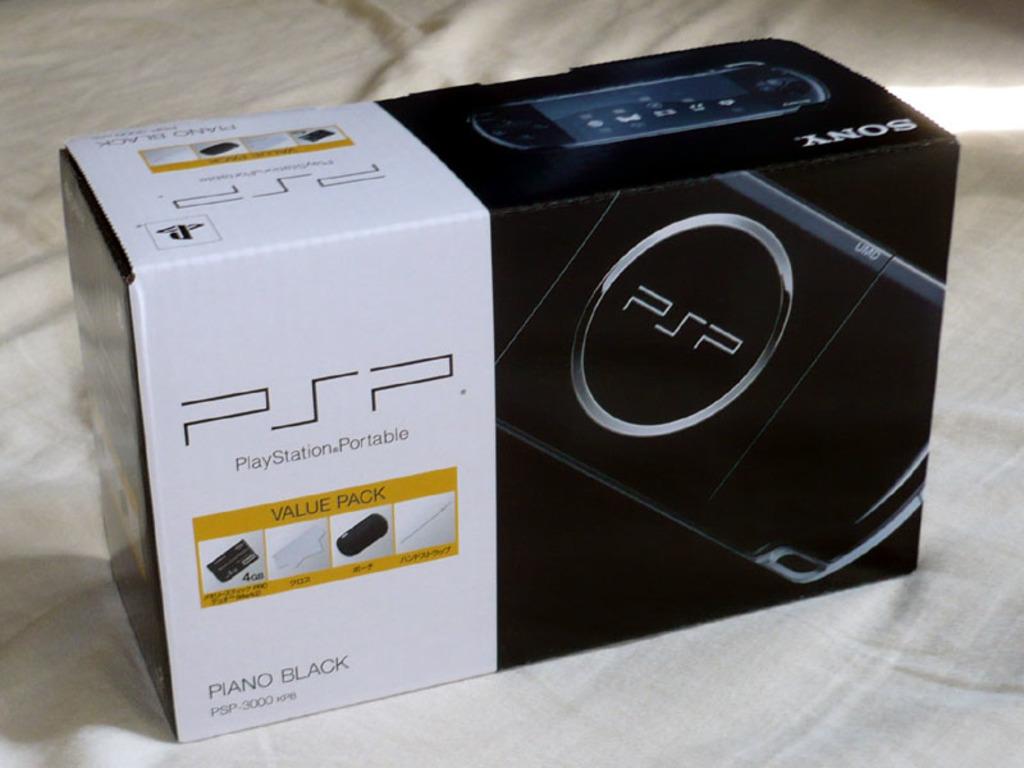What kind of game system is this?
Keep it short and to the point. Psp. 